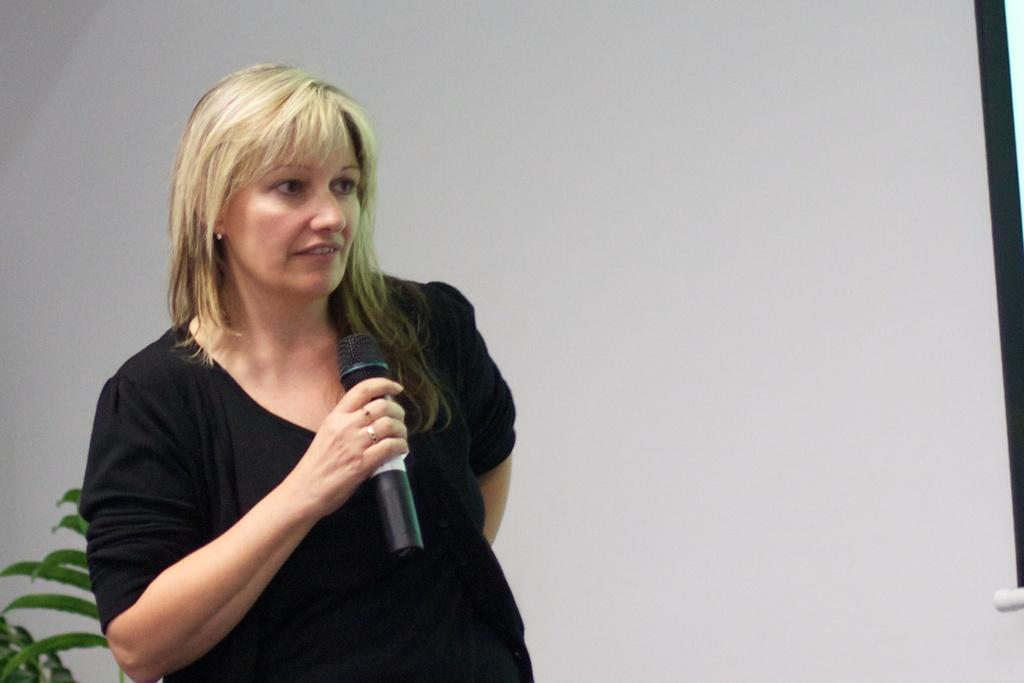Who is present in the image? There is a person (she) in the image. What is the person doing in the image? The person is standing in the image. What object is the person holding in the image? The person is holding a microphone (mike) in the image. What type of vegetation can be seen in the image? There is a plant in the image. What color is the background of the image? The background of the image is white. What type of industry can be seen in the background of the image? There is no industry visible in the image; the background is white. How does the person find their way in the image? The image does not depict a situation where the person needs to find their way; they are simply standing with a microphone. 